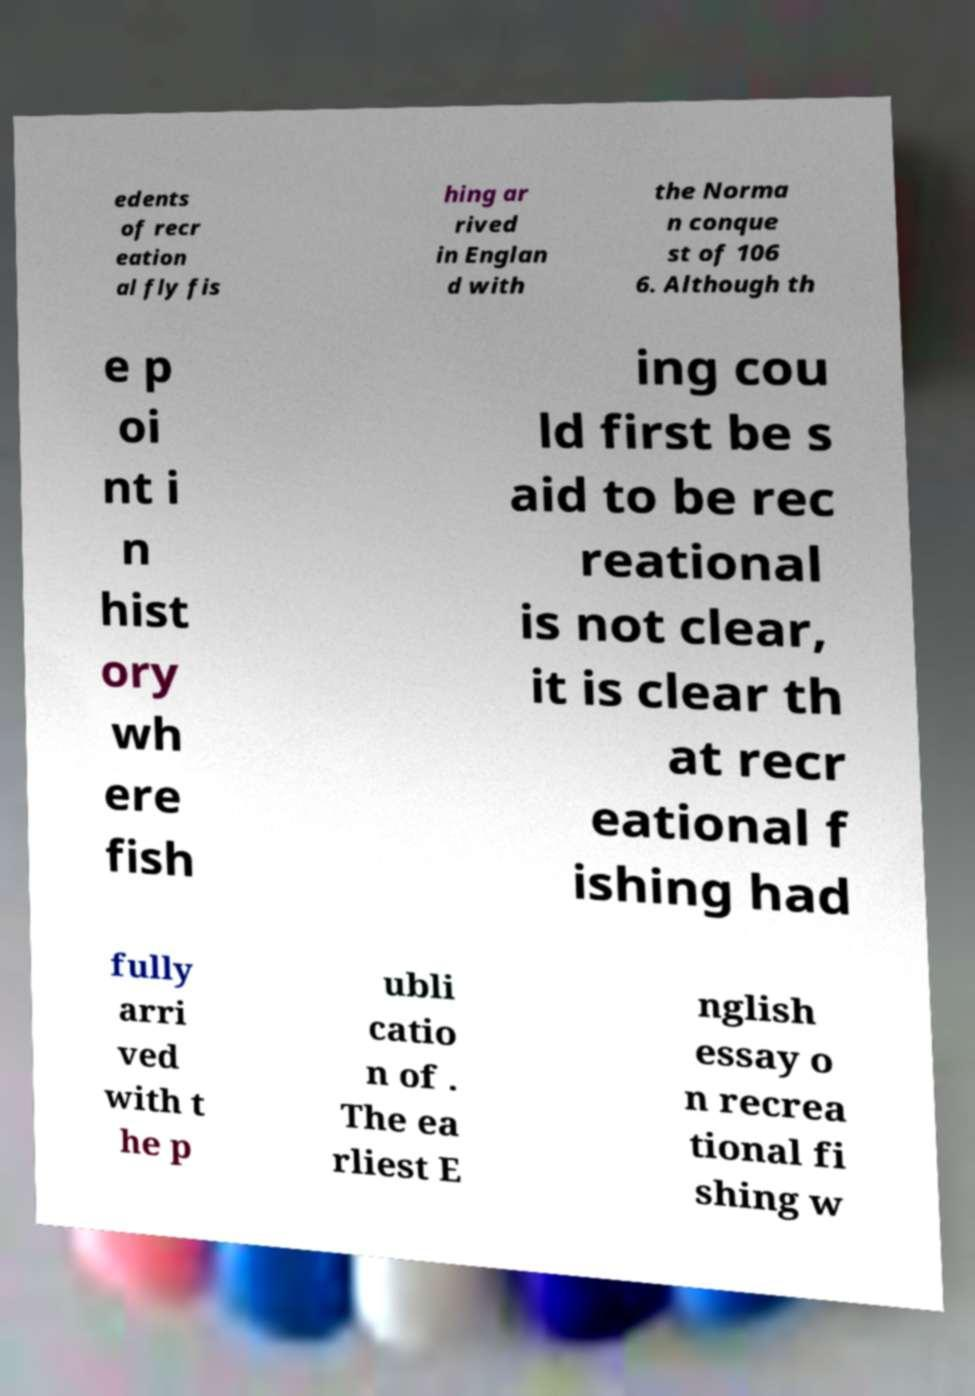Can you accurately transcribe the text from the provided image for me? edents of recr eation al fly fis hing ar rived in Englan d with the Norma n conque st of 106 6. Although th e p oi nt i n hist ory wh ere fish ing cou ld first be s aid to be rec reational is not clear, it is clear th at recr eational f ishing had fully arri ved with t he p ubli catio n of . The ea rliest E nglish essay o n recrea tional fi shing w 